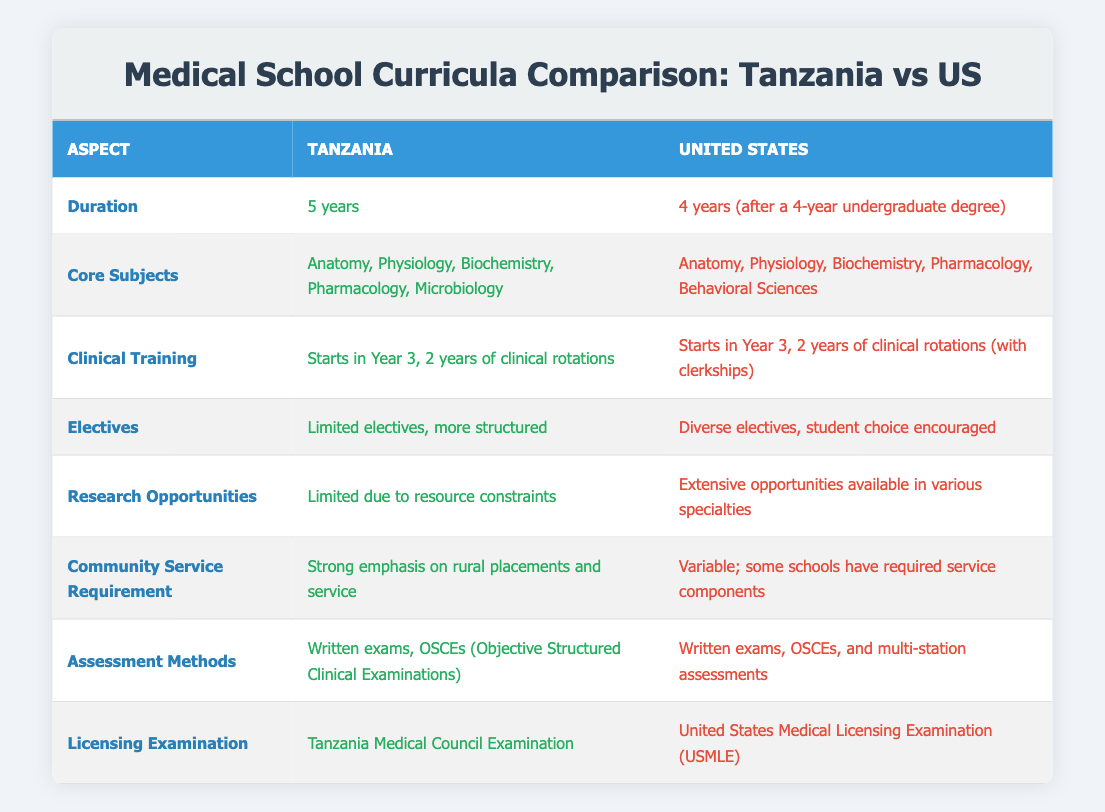What is the duration of medical school in Tanzania? The table shows that the duration of medical school in Tanzania is listed clearly under the "Duration" row. It states "5 years."
Answer: 5 years What core subjects are taught in the US medical schools? Under the "Core Subjects" row, the table specifies that US medical schools include "Anatomy, Physiology, Biochemistry, Pharmacology, Behavioral Sciences."
Answer: Anatomy, Physiology, Biochemistry, Pharmacology, Behavioral Sciences Is clinical training in Tanzania initiated in the third year? The table indicates that clinical training in Tanzania starts in Year 3 according to its information in the "Clinical Training" row, which confirms this fact.
Answer: Yes How does the duration of medical schooling compare between Tanzania and the US? From the "Duration" aspect, Tanzania has 5 years compared to 4 years in the US. So, Tanzania's curriculum is longer by 1 year.
Answer: Tanzania is longer by 1 year Are there more research opportunities available in the US compared to Tanzania? The table notes that the US has "extensive opportunities available in various specialties," while Tanzania has "limited due to resource constraints." This indicates a clear difference.
Answer: Yes What are the differences in assessment methods between Tanzania and the US? The "Assessment Methods" row shows that Tanzania uses "Written exams, OSCEs," while the US includes "Written exams, OSCEs, and multi-station assessments." The US has an additional assessment method.
Answer: US includes multi-station assessments Based on the table, what are the implications of the elective offerings in both countries? The "Electives" row indicates that Tanzania has "Limited electives, more structured," while the US offers "Diverse electives, student choice encouraged." This implies that US students have more flexibility and options in their studies.
Answer: US offers more flexibility and options Is there a community service requirement in US medical schools according to the table? The "Community Service Requirement" row states that in the US, "some schools have required service components," which suggests variability but confirms that it exists in some cases.
Answer: Yes How would you summarize the licensing examination process between Tanzania and the US? From the "Licensing Examination" row, Tanzania requires passing the "Tanzania Medical Council Examination," while the US requires the "United States Medical Licensing Examination (USMLE)." This shows that both countries have different examinations for licensure.
Answer: Different examinations for licensure 